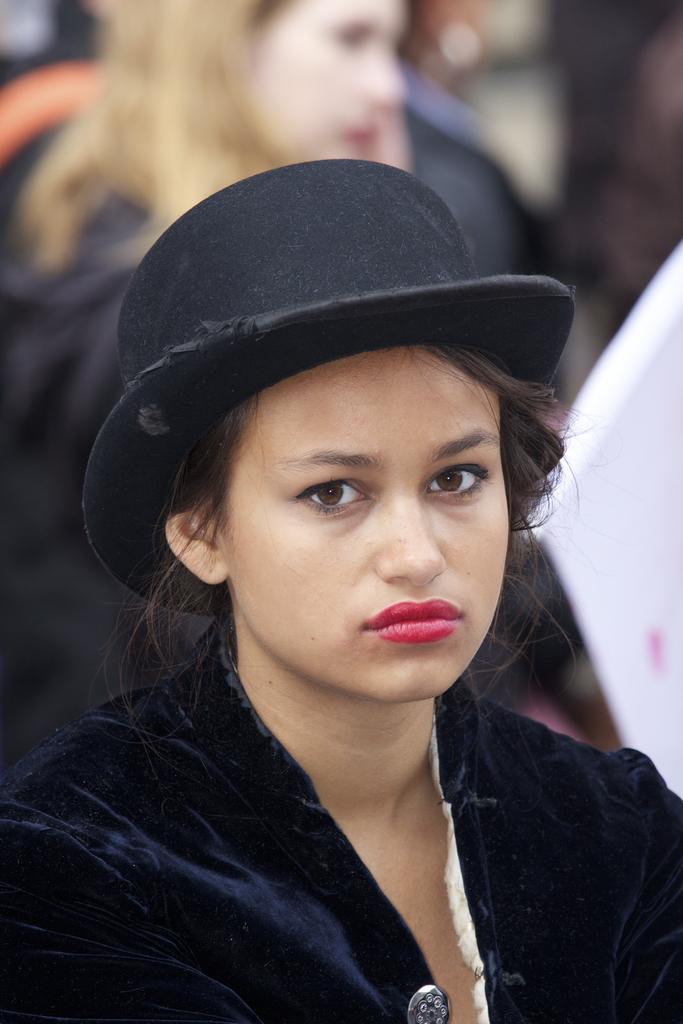What is the woman in the image wearing on her head? There is a woman wearing a black cap in the image. What is the woman doing in the image? The woman is watching something. Can you describe the presence of other people in the image? There is another woman in the background of the image. How would you describe the background of the image? The background of the image is blurred. What type of pan is being used to cook the bun in the image? There is no pan or bun present in the image. Is there a fire visible in the image? No, there is no fire visible in the image. 